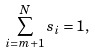Convert formula to latex. <formula><loc_0><loc_0><loc_500><loc_500>\sum _ { i = m + 1 } ^ { N } s _ { i } = 1 ,</formula> 